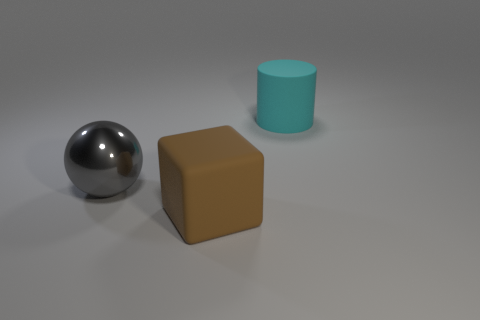Add 2 yellow cylinders. How many objects exist? 5 Subtract all cubes. How many objects are left? 2 Add 3 big brown blocks. How many big brown blocks are left? 4 Add 1 large blue spheres. How many large blue spheres exist? 1 Subtract 0 gray blocks. How many objects are left? 3 Subtract all cylinders. Subtract all blue shiny cylinders. How many objects are left? 2 